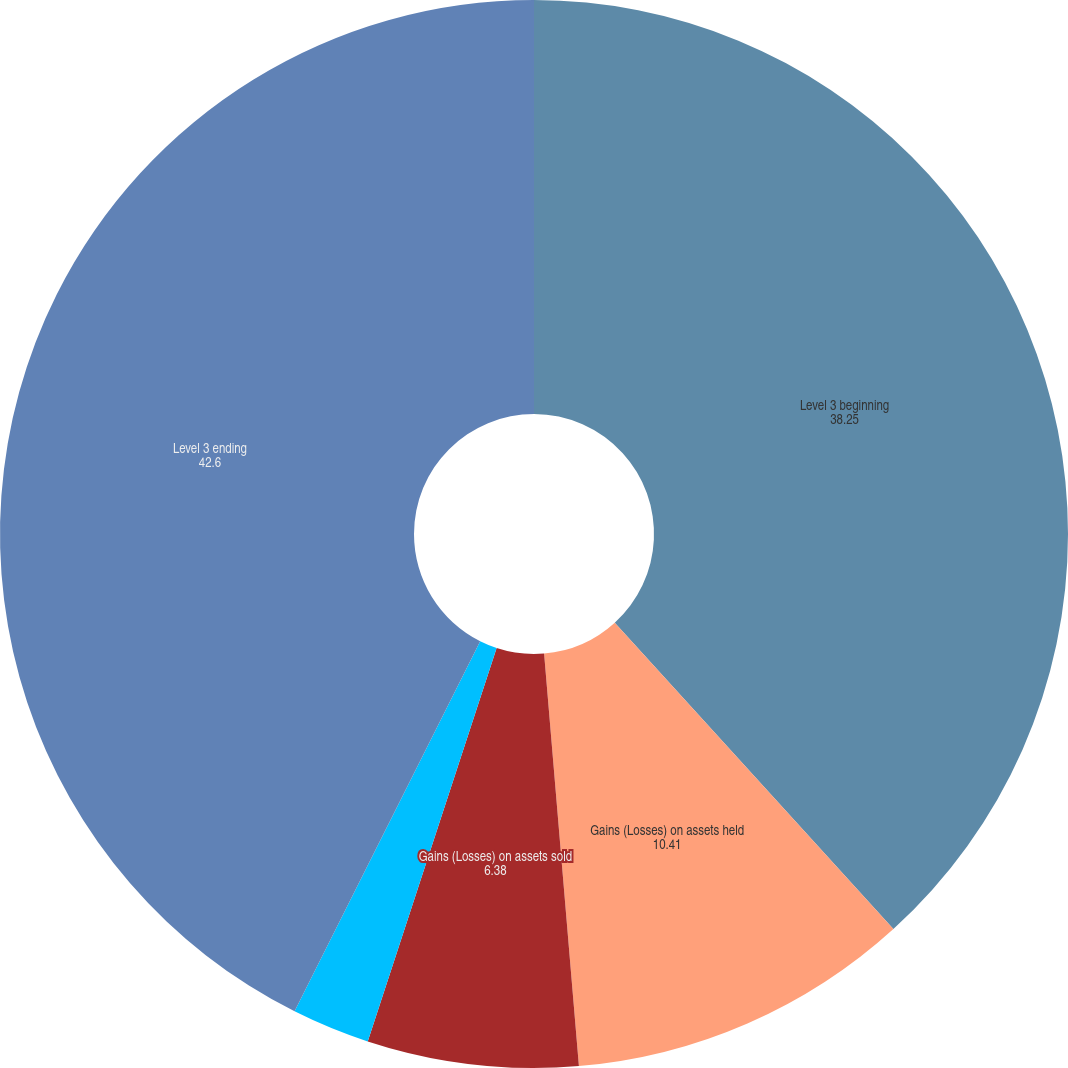<chart> <loc_0><loc_0><loc_500><loc_500><pie_chart><fcel>Level 3 beginning<fcel>Gains (Losses) on assets held<fcel>Gains (Losses) on assets sold<fcel>Purchases sales and<fcel>Level 3 ending<nl><fcel>38.25%<fcel>10.41%<fcel>6.38%<fcel>2.36%<fcel>42.6%<nl></chart> 